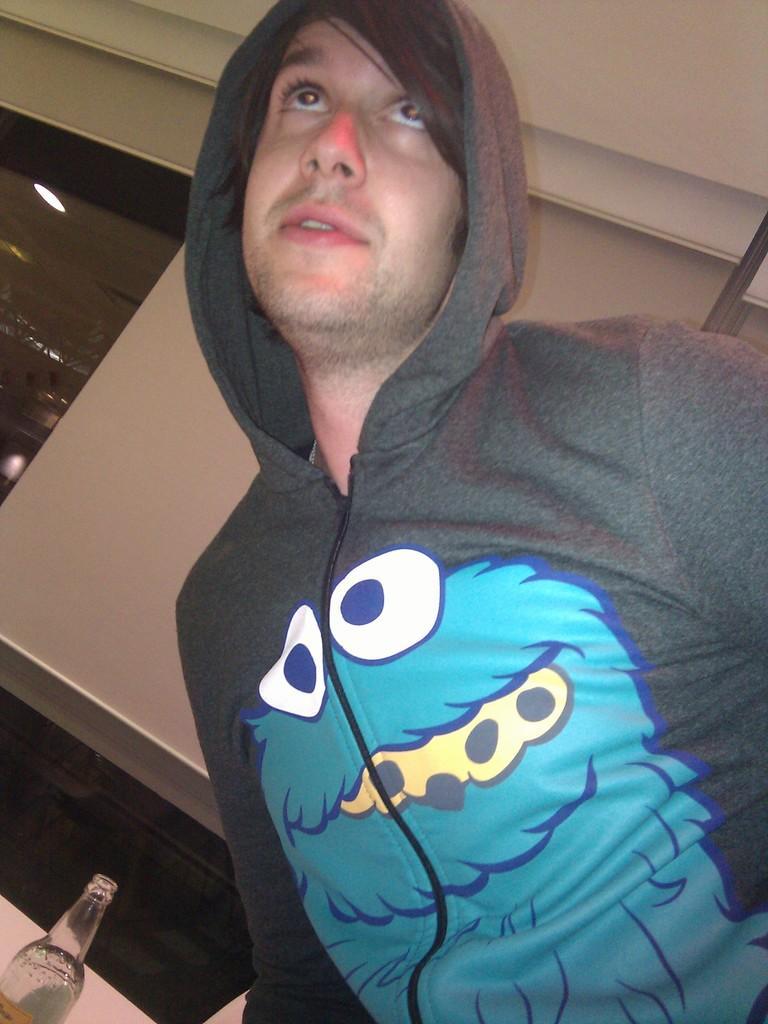Please provide a concise description of this image. In this Image I see man who is wearing a hoodie and there is a bottle over here, In the background I see the light on the ceiling. 